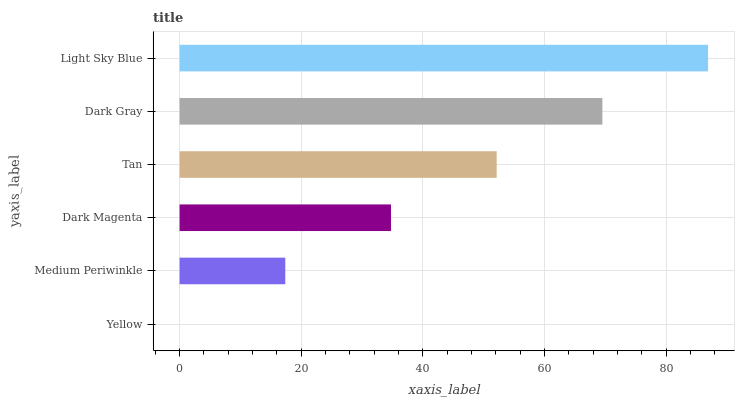Is Yellow the minimum?
Answer yes or no. Yes. Is Light Sky Blue the maximum?
Answer yes or no. Yes. Is Medium Periwinkle the minimum?
Answer yes or no. No. Is Medium Periwinkle the maximum?
Answer yes or no. No. Is Medium Periwinkle greater than Yellow?
Answer yes or no. Yes. Is Yellow less than Medium Periwinkle?
Answer yes or no. Yes. Is Yellow greater than Medium Periwinkle?
Answer yes or no. No. Is Medium Periwinkle less than Yellow?
Answer yes or no. No. Is Tan the high median?
Answer yes or no. Yes. Is Dark Magenta the low median?
Answer yes or no. Yes. Is Dark Magenta the high median?
Answer yes or no. No. Is Medium Periwinkle the low median?
Answer yes or no. No. 